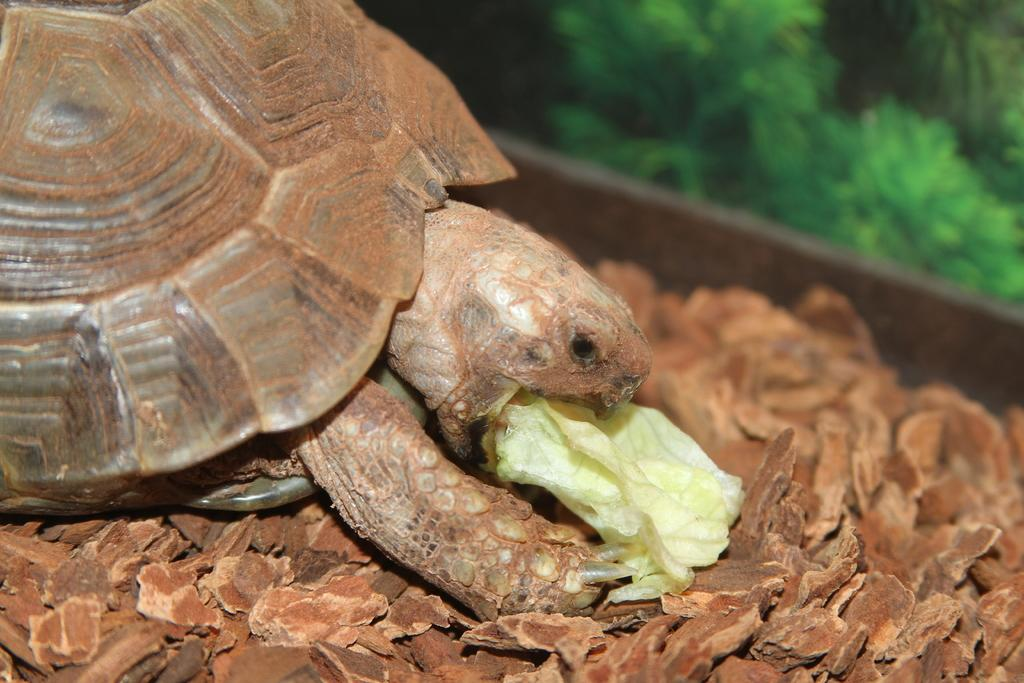What animal is present in the image? There is a turtle in the image. What is the turtle doing in the image? The turtle is eating something in the image. What can be seen at the bottom of the image? There are stones at the bottom of the image. What type of vegetation is visible in the background of the image? There are plants in the background of the image. Can you hear the turtle's aunt talking to the kettle in the image? There is no mention of an aunt or a kettle in the image, and the turtle cannot talk. 